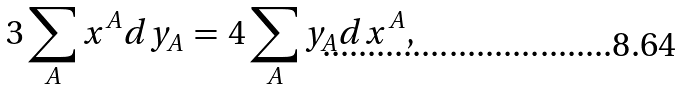Convert formula to latex. <formula><loc_0><loc_0><loc_500><loc_500>3 \sum _ { A } x ^ { A } d y _ { A } \, = \, 4 \sum _ { A } y _ { A } d x ^ { A } ,</formula> 